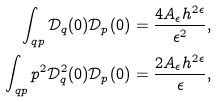<formula> <loc_0><loc_0><loc_500><loc_500>\int _ { q p } \mathcal { D } _ { q } ( 0 ) \mathcal { D } _ { p } ( 0 ) = \frac { 4 A _ { \epsilon } h ^ { 2 \epsilon } } { \epsilon ^ { 2 } } , \\ \int _ { q p } p ^ { 2 } \mathcal { D } ^ { 2 } _ { q } ( 0 ) \mathcal { D } _ { p } ( 0 ) = \frac { 2 A _ { \epsilon } h ^ { 2 \epsilon } } { \epsilon } ,</formula> 